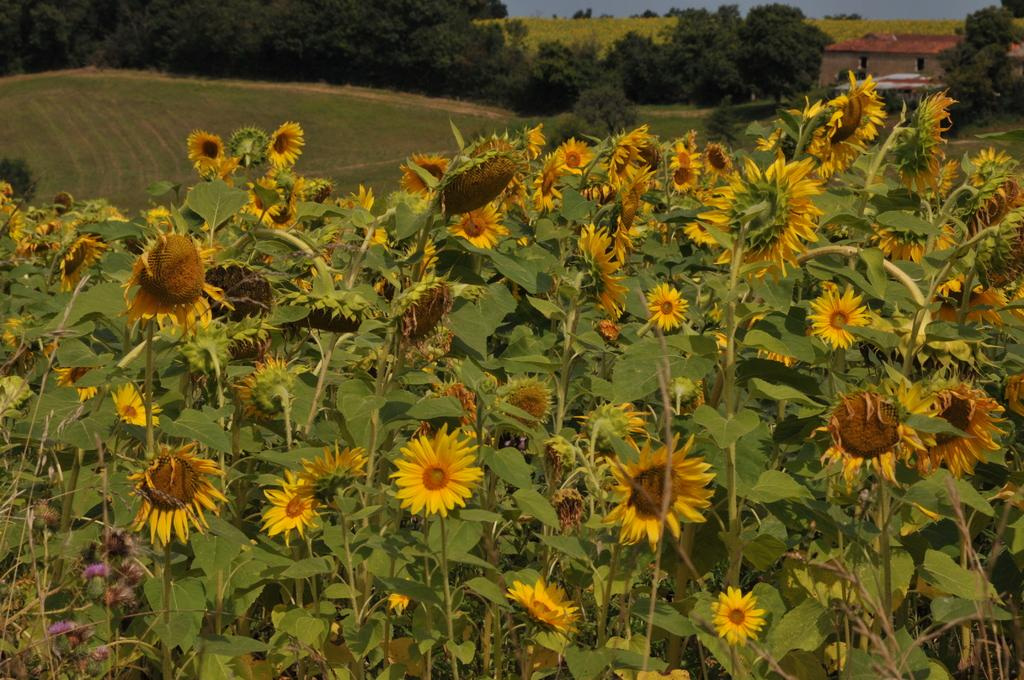What type of plants can be seen in the image? There are sunflowers in the image. What type of vegetation is present in the image besides sunflowers? There is grass in the image. Are there any other plants or structures visible in the image? Yes, there are trees in the image. What can be seen in the background of the image? There is a building at the right back of the image. What type of music can be heard playing in the background of the image? There is no music present in the image, as it is a still photograph. 